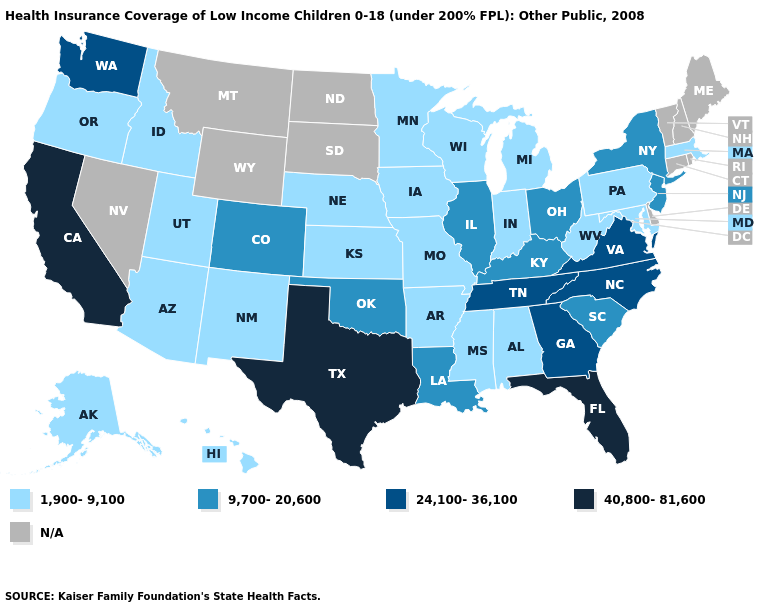Which states have the highest value in the USA?
Answer briefly. California, Florida, Texas. Does the map have missing data?
Short answer required. Yes. Name the states that have a value in the range 24,100-36,100?
Answer briefly. Georgia, North Carolina, Tennessee, Virginia, Washington. Name the states that have a value in the range N/A?
Give a very brief answer. Connecticut, Delaware, Maine, Montana, Nevada, New Hampshire, North Dakota, Rhode Island, South Dakota, Vermont, Wyoming. Does Pennsylvania have the highest value in the Northeast?
Quick response, please. No. Name the states that have a value in the range 1,900-9,100?
Quick response, please. Alabama, Alaska, Arizona, Arkansas, Hawaii, Idaho, Indiana, Iowa, Kansas, Maryland, Massachusetts, Michigan, Minnesota, Mississippi, Missouri, Nebraska, New Mexico, Oregon, Pennsylvania, Utah, West Virginia, Wisconsin. Does the map have missing data?
Write a very short answer. Yes. Name the states that have a value in the range 9,700-20,600?
Give a very brief answer. Colorado, Illinois, Kentucky, Louisiana, New Jersey, New York, Ohio, Oklahoma, South Carolina. Does the first symbol in the legend represent the smallest category?
Write a very short answer. Yes. What is the lowest value in the USA?
Quick response, please. 1,900-9,100. What is the highest value in the USA?
Answer briefly. 40,800-81,600. What is the lowest value in the USA?
Give a very brief answer. 1,900-9,100. Name the states that have a value in the range 9,700-20,600?
Give a very brief answer. Colorado, Illinois, Kentucky, Louisiana, New Jersey, New York, Ohio, Oklahoma, South Carolina. Name the states that have a value in the range 9,700-20,600?
Keep it brief. Colorado, Illinois, Kentucky, Louisiana, New Jersey, New York, Ohio, Oklahoma, South Carolina. Which states have the lowest value in the West?
Write a very short answer. Alaska, Arizona, Hawaii, Idaho, New Mexico, Oregon, Utah. 